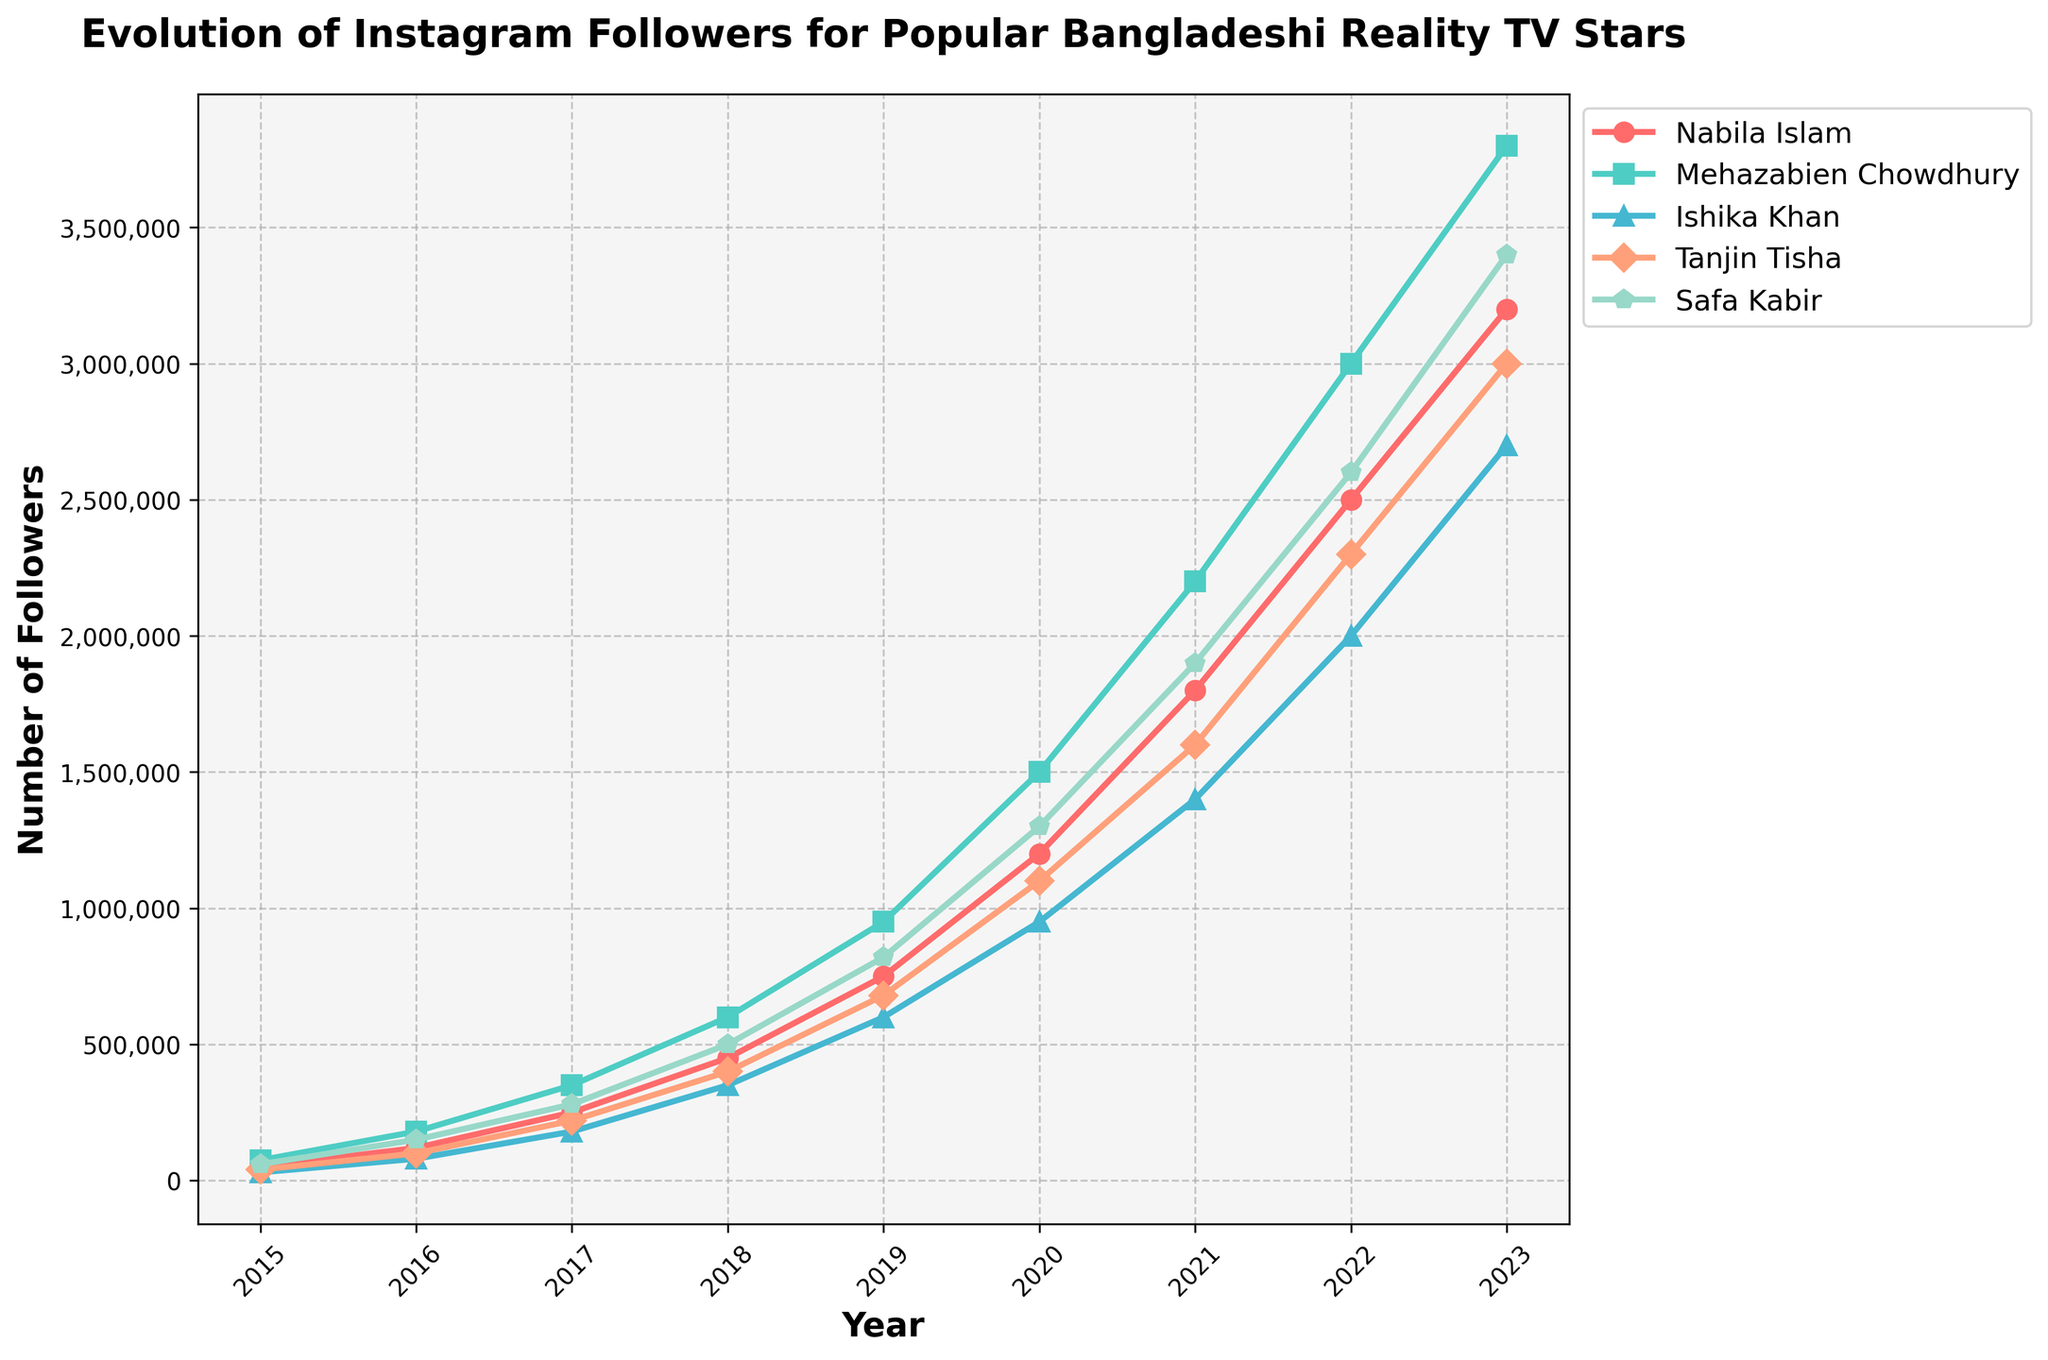Which star has the highest number of followers in 2023? Refer to the plot and look at the end of the lines for the year 2023. Mehazabien Chowdhury has the highest number of followers in 2023.
Answer: Mehazabien Chowdhury Who had the most significant increase in followers between 2015 and 2023? Calculate the difference in followers from 2015 to 2023 for each star. Mehazabien Chowdhury had the greatest increase, from 75,000 to 3,800,000, a change of 3,725,000.
Answer: Mehazabien Chowdhury How many followers did Nabila Islam have in 2020? Look at the line representing Nabila Islam in 2020 on the plot. She had 1,200,000 followers in 2020.
Answer: 1,200,000 Which star reached 1 million followers first, and in what year? Observe the plot and identify which line first crosses the 1 million mark. Mehazabien Chowdhury reached 1 million followers first in 2019.
Answer: Mehazabien Chowdhury, 2019 Between 2016 and 2018, which star had the fastest growth rate? Calculate the growth rate for each star between 2016 and 2018. Growth rate can be estimated by the steepness of the line. Mehazabien Chowdhury had the fastest growth, increasing from 180,000 to 600,000 followers.
Answer: Mehazabien Chowdhury Compare the number of followers of Ishika Khan and Safa Kabir in 2017. Who had more followers, and by how much? Look at the plot for the year 2017. Ishika Khan had 180,000 followers, and Safa Kabir had 280,000 followers. Safa Kabir had more followers by 100,000.
Answer: Safa Kabir, 100,000 What was the average number of followers for all five stars in 2022? Add the number of followers for each star in 2022 and divide by 5. (2,500,000 + 3,000,000 + 2,000,000 + 2,300,000 + 2,600,000) / 5 = 2,480,000.
Answer: 2,480,000 Which star had the least growth in followers from 2018 to 2023? Calculate the difference in followers from 2018 to 2023 for each star. Ishika Khan had the smallest increase, from 350,000 to 2,700,000, an increase of 2,350,000.
Answer: Ishika Khan In which year did Tanjin Tisha surpass 1 million followers? Observe the plot for Tanjin Tisha and find the year when her follower count first exceeds 1 million. This happened in 2020.
Answer: 2020 How many total followers did the five stars have combined in 2019? Add the number of followers for each star in 2019. 750,000 + 950,000 + 600,000 + 680,000 + 820,000 = 3,800,000.
Answer: 3,800,000 